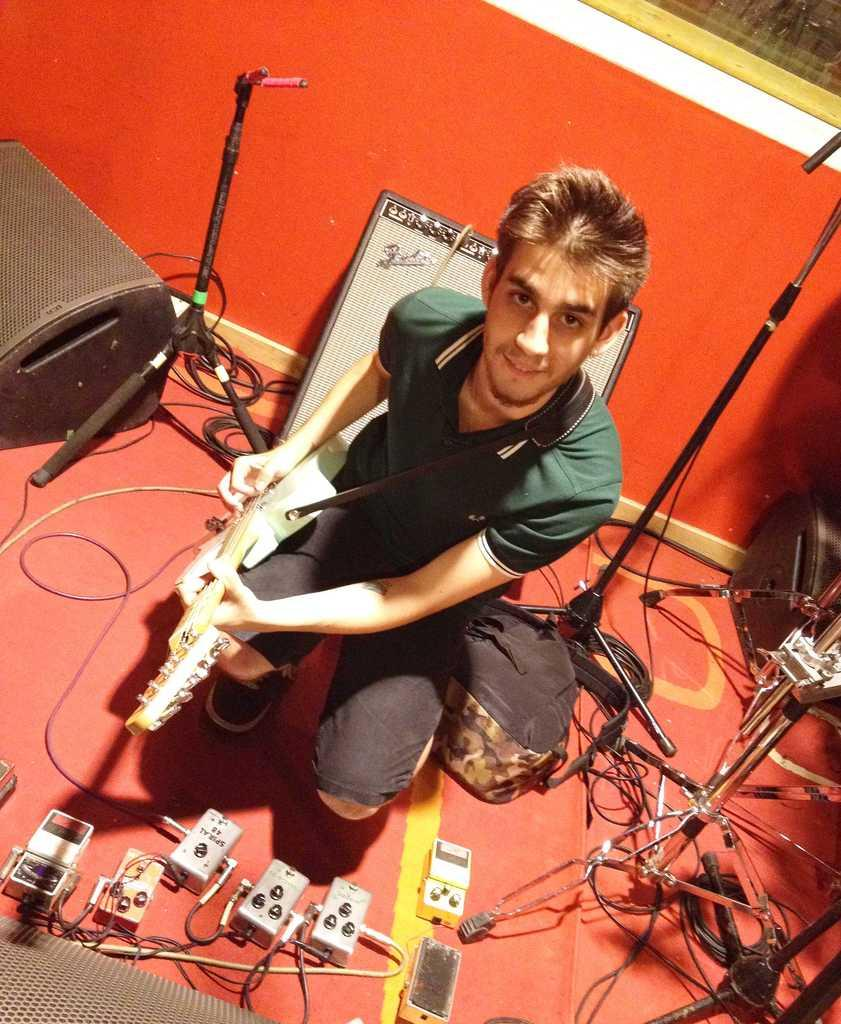What is the man in the image doing? The man is playing a guitar in the image. Where is the guitar located in relation to the man? The guitar is in the middle of the image. What else can be seen on the floor in the image? There are other objects on the floor. What is visible in the background of the image? There is a wall in the background of the image. What type of self-defense technique is the man demonstrating in the image? There is no self-defense technique being demonstrated in the image; the man is playing a guitar. Is there a skateboard visible in the image? No, there is no skateboard present in the image. 